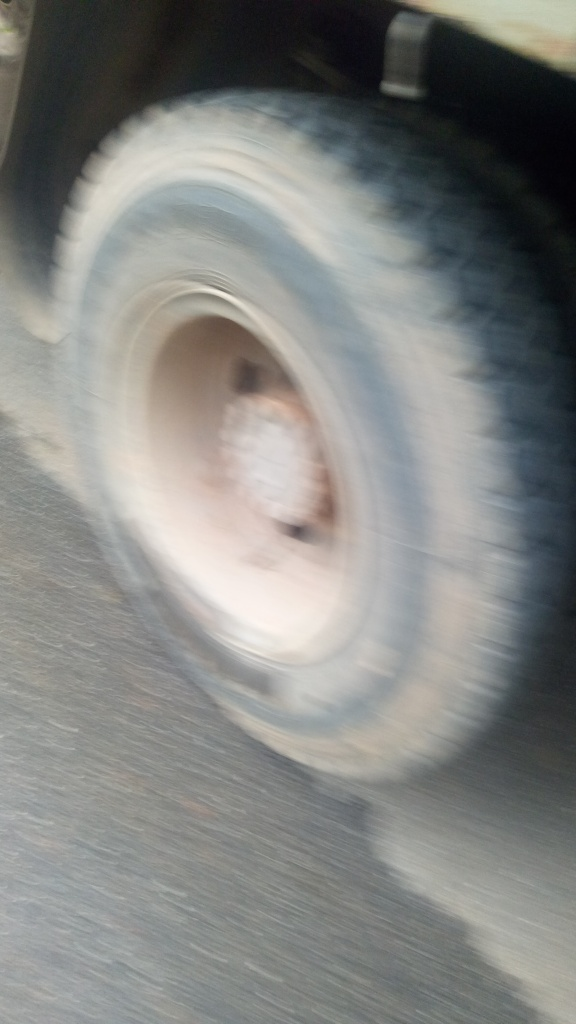The image is very blurry; does this affect our ability to understand its content? Absolutely, the blurriness significantly affects our ability to comprehend the full content of the image. Details are obscured, making it difficult to determine the make and model of the vehicle, the state of the tire, and any other potential points of interest that might be in the frame. The blurriness largely restricts our interpretation to general observations, such as the motion of the vehicle. 